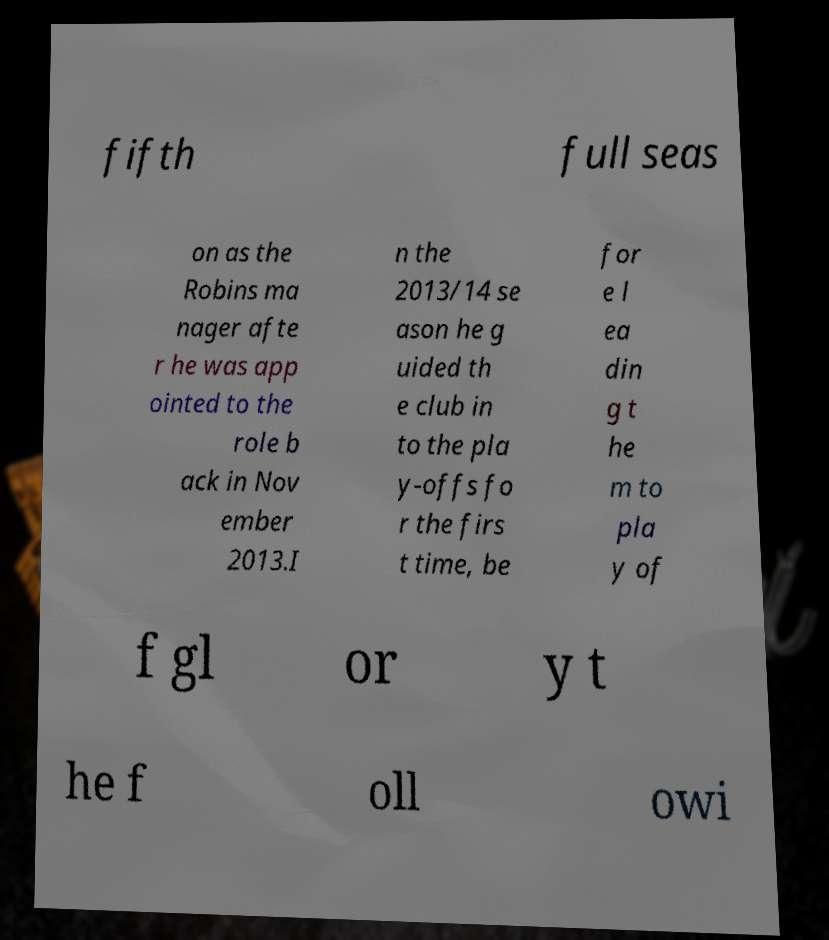Could you extract and type out the text from this image? fifth full seas on as the Robins ma nager afte r he was app ointed to the role b ack in Nov ember 2013.I n the 2013/14 se ason he g uided th e club in to the pla y-offs fo r the firs t time, be for e l ea din g t he m to pla y of f gl or y t he f oll owi 